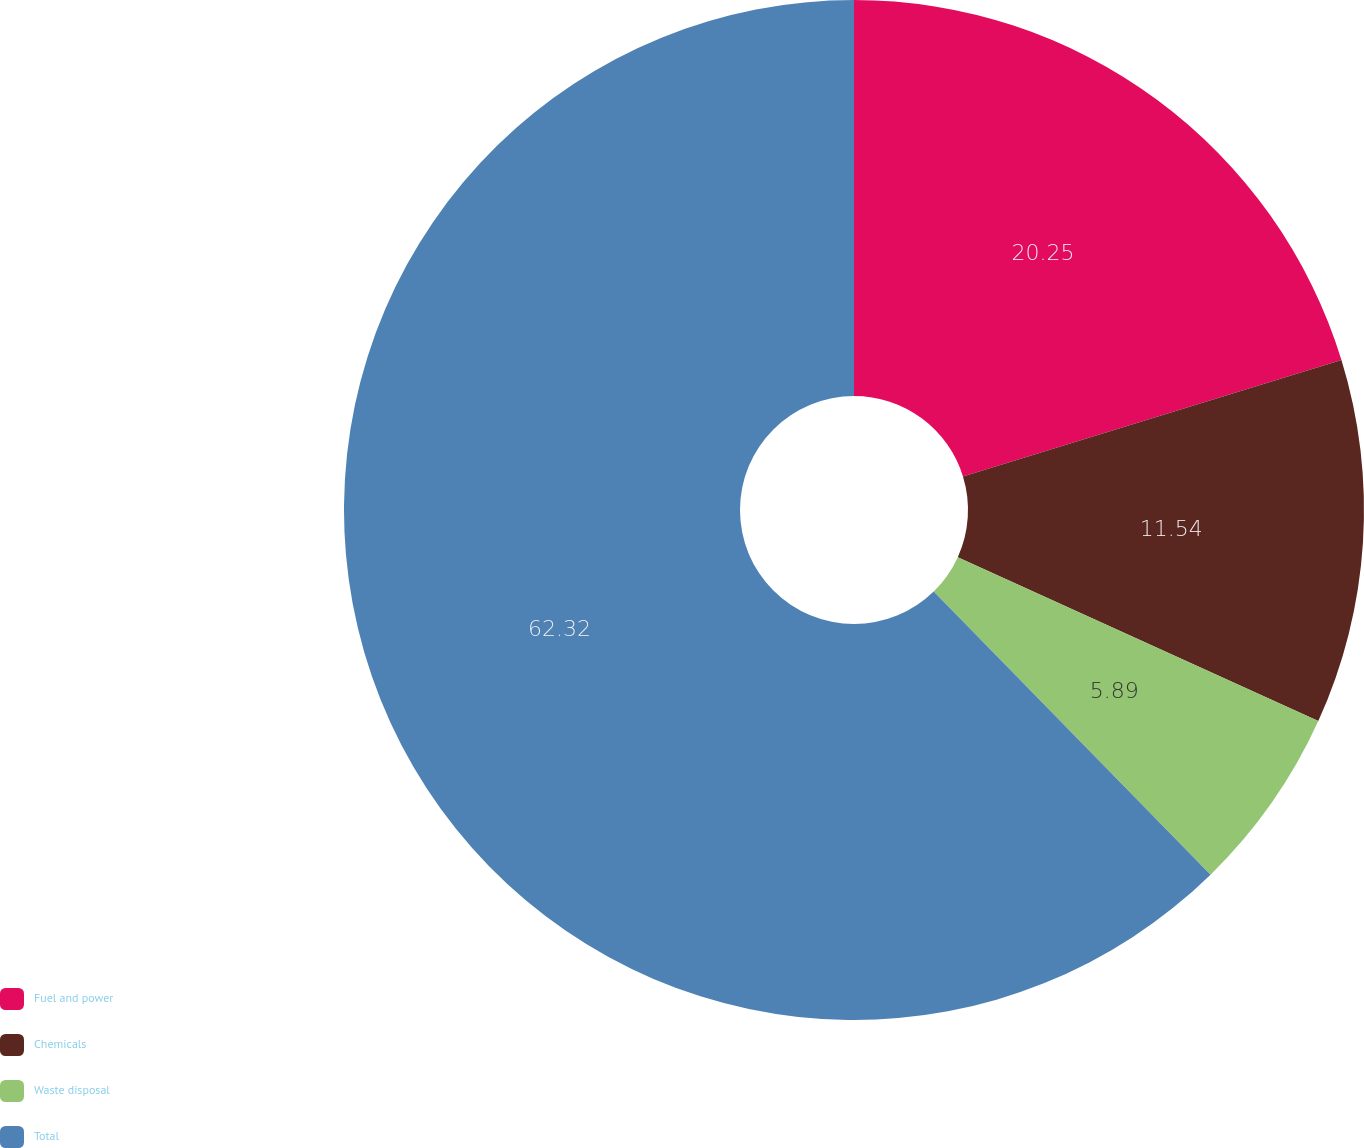<chart> <loc_0><loc_0><loc_500><loc_500><pie_chart><fcel>Fuel and power<fcel>Chemicals<fcel>Waste disposal<fcel>Total<nl><fcel>20.25%<fcel>11.54%<fcel>5.89%<fcel>62.32%<nl></chart> 